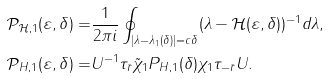<formula> <loc_0><loc_0><loc_500><loc_500>\mathcal { P } _ { \mathcal { H } , 1 } ( \varepsilon , \delta ) = & \frac { 1 } { 2 \pi i } \oint _ { | \lambda - \lambda _ { 1 } ( \delta ) | = c \delta } ( \lambda - \mathcal { H } ( \varepsilon , \delta ) ) ^ { - 1 } d \lambda , \\ \mathcal { P } _ { H , 1 } ( \varepsilon , \delta ) = & U ^ { - 1 } \tau _ { \bar { r } } \tilde { \chi } _ { 1 } P _ { H , 1 } ( \delta ) \chi _ { 1 } \tau _ { - \bar { r } } U .</formula> 